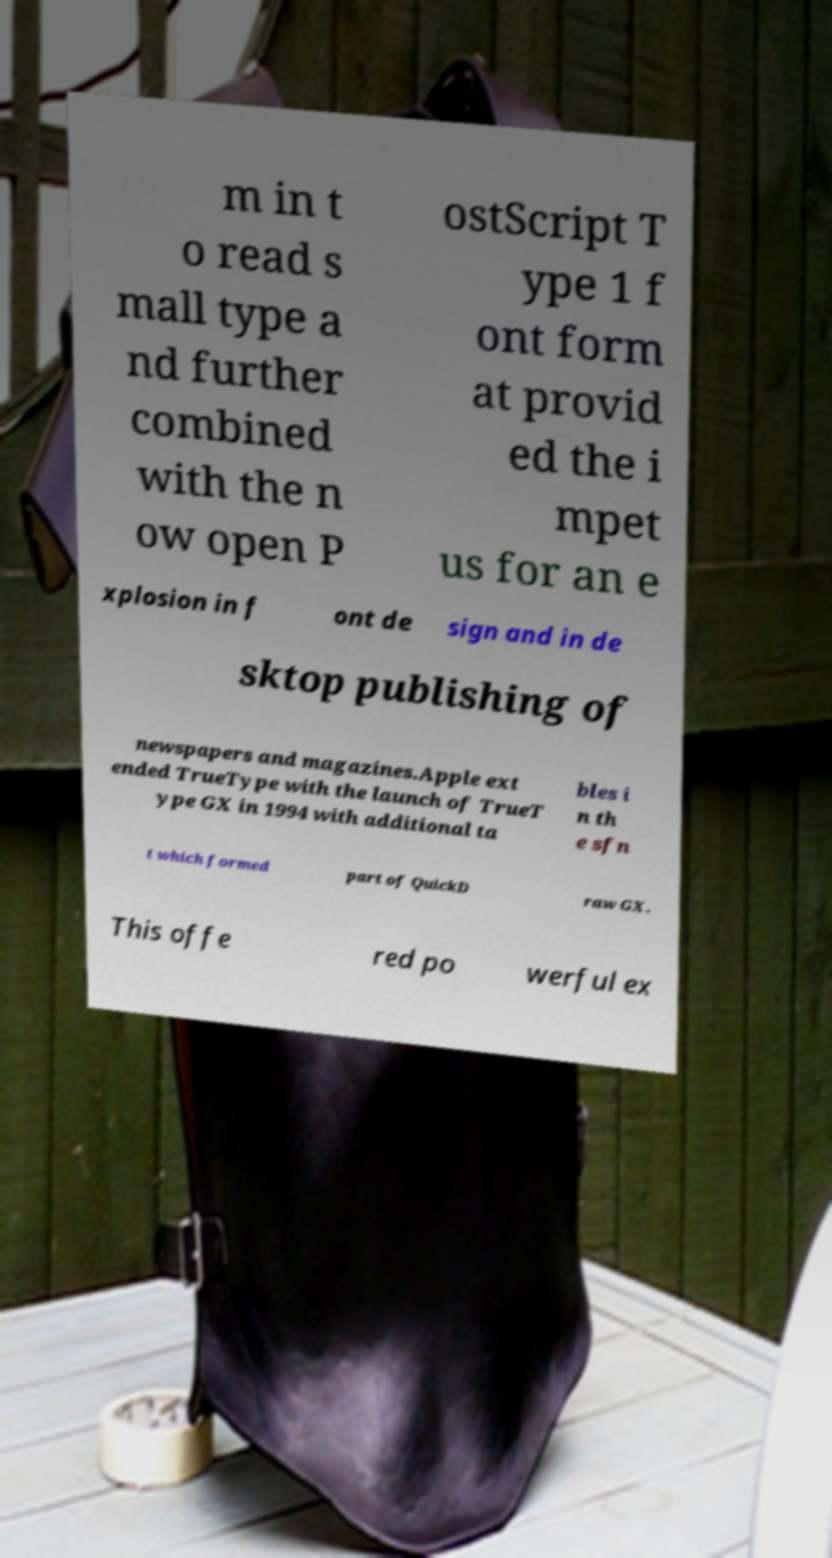For documentation purposes, I need the text within this image transcribed. Could you provide that? m in t o read s mall type a nd further combined with the n ow open P ostScript T ype 1 f ont form at provid ed the i mpet us for an e xplosion in f ont de sign and in de sktop publishing of newspapers and magazines.Apple ext ended TrueType with the launch of TrueT ype GX in 1994 with additional ta bles i n th e sfn t which formed part of QuickD raw GX. This offe red po werful ex 